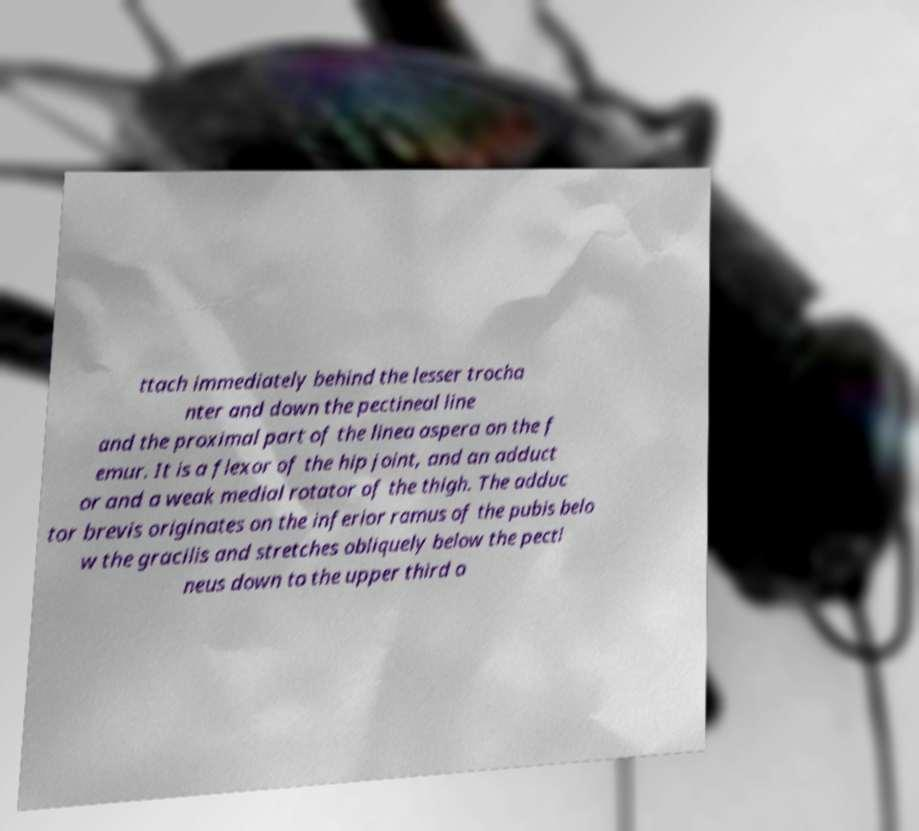Can you read and provide the text displayed in the image?This photo seems to have some interesting text. Can you extract and type it out for me? ttach immediately behind the lesser trocha nter and down the pectineal line and the proximal part of the linea aspera on the f emur. It is a flexor of the hip joint, and an adduct or and a weak medial rotator of the thigh. The adduc tor brevis originates on the inferior ramus of the pubis belo w the gracilis and stretches obliquely below the pecti neus down to the upper third o 